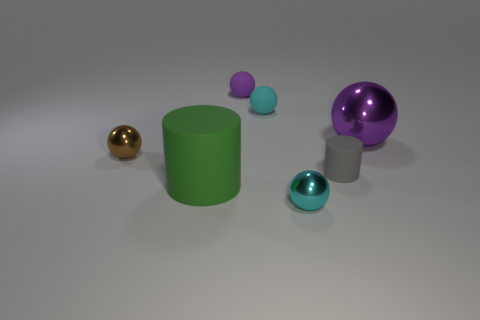Is there anything else that is the same size as the cyan shiny ball?
Your answer should be compact. Yes. Is there a tiny purple thing made of the same material as the large sphere?
Keep it short and to the point. No. Are there more small metallic objects that are behind the big purple metallic object than tiny objects that are to the right of the small purple sphere?
Your answer should be very brief. No. The purple rubber thing is what size?
Offer a very short reply. Small. What shape is the purple object that is behind the big purple thing?
Offer a very short reply. Sphere. Does the cyan metal thing have the same shape as the large green thing?
Provide a short and direct response. No. Is the number of cyan metal objects behind the big green object the same as the number of things?
Keep it short and to the point. No. What is the shape of the tiny purple matte object?
Provide a succinct answer. Sphere. Is there anything else that has the same color as the big rubber cylinder?
Your response must be concise. No. There is a shiny ball that is to the left of the tiny purple rubber object; is it the same size as the cyan sphere that is in front of the small gray thing?
Your response must be concise. Yes. 